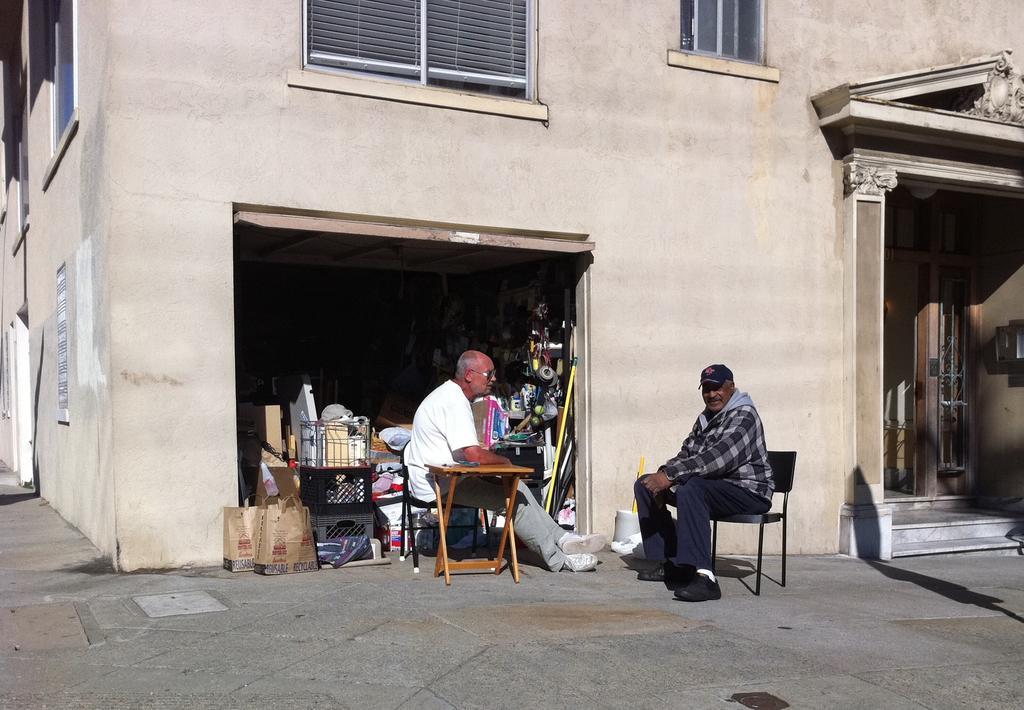Could you give a brief overview of what you see in this image? This is an outside view. At the bottom, I can see the ground. Here I can see a building along with the windows. In front of this building two men are sitting on the chairs and there is a table. Here it seems like a room. There are many objects placed on the floor. 